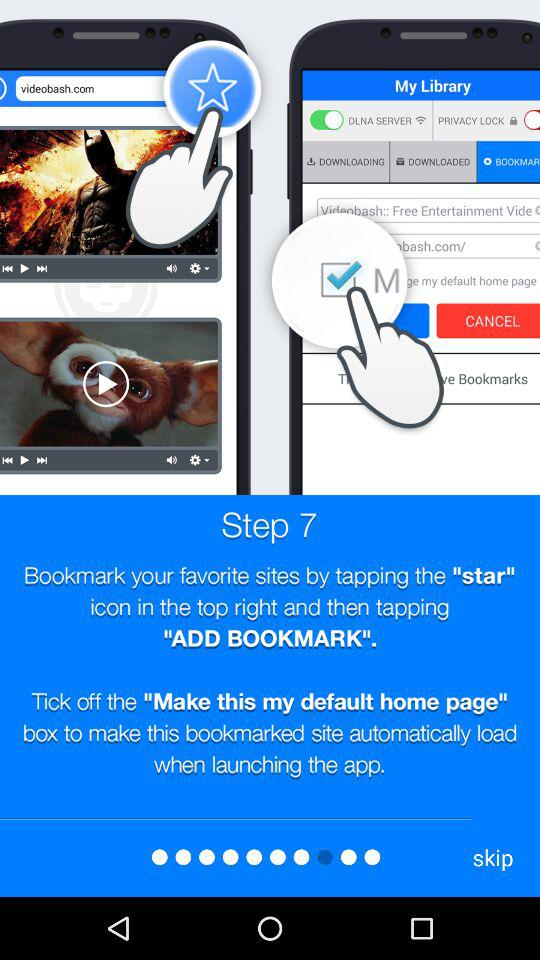How to add bookmark? To add a bookmark : "Bookmark your favourite sites by tapping the "star" icon in the top right and then tapping "ADD BOOKMARK"". 